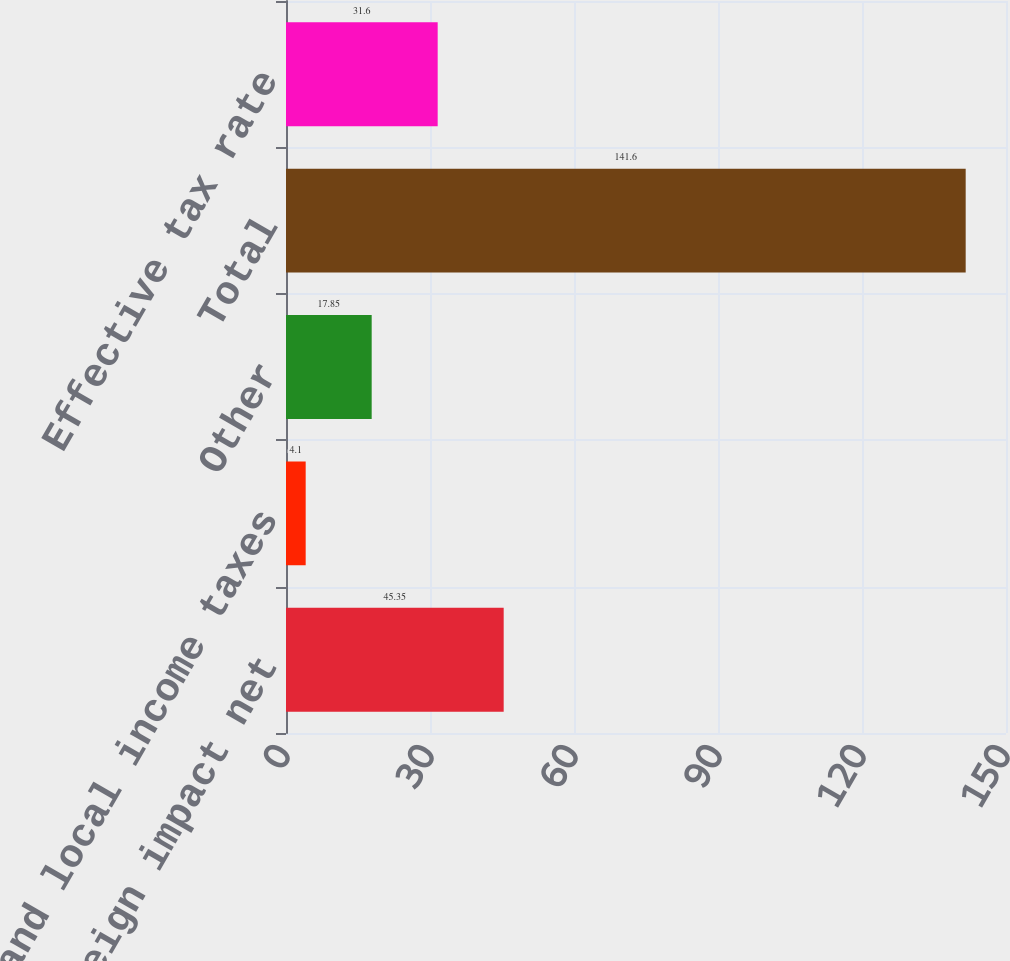Convert chart. <chart><loc_0><loc_0><loc_500><loc_500><bar_chart><fcel>Foreign impact net<fcel>State and local income taxes<fcel>Other<fcel>Total<fcel>Effective tax rate<nl><fcel>45.35<fcel>4.1<fcel>17.85<fcel>141.6<fcel>31.6<nl></chart> 